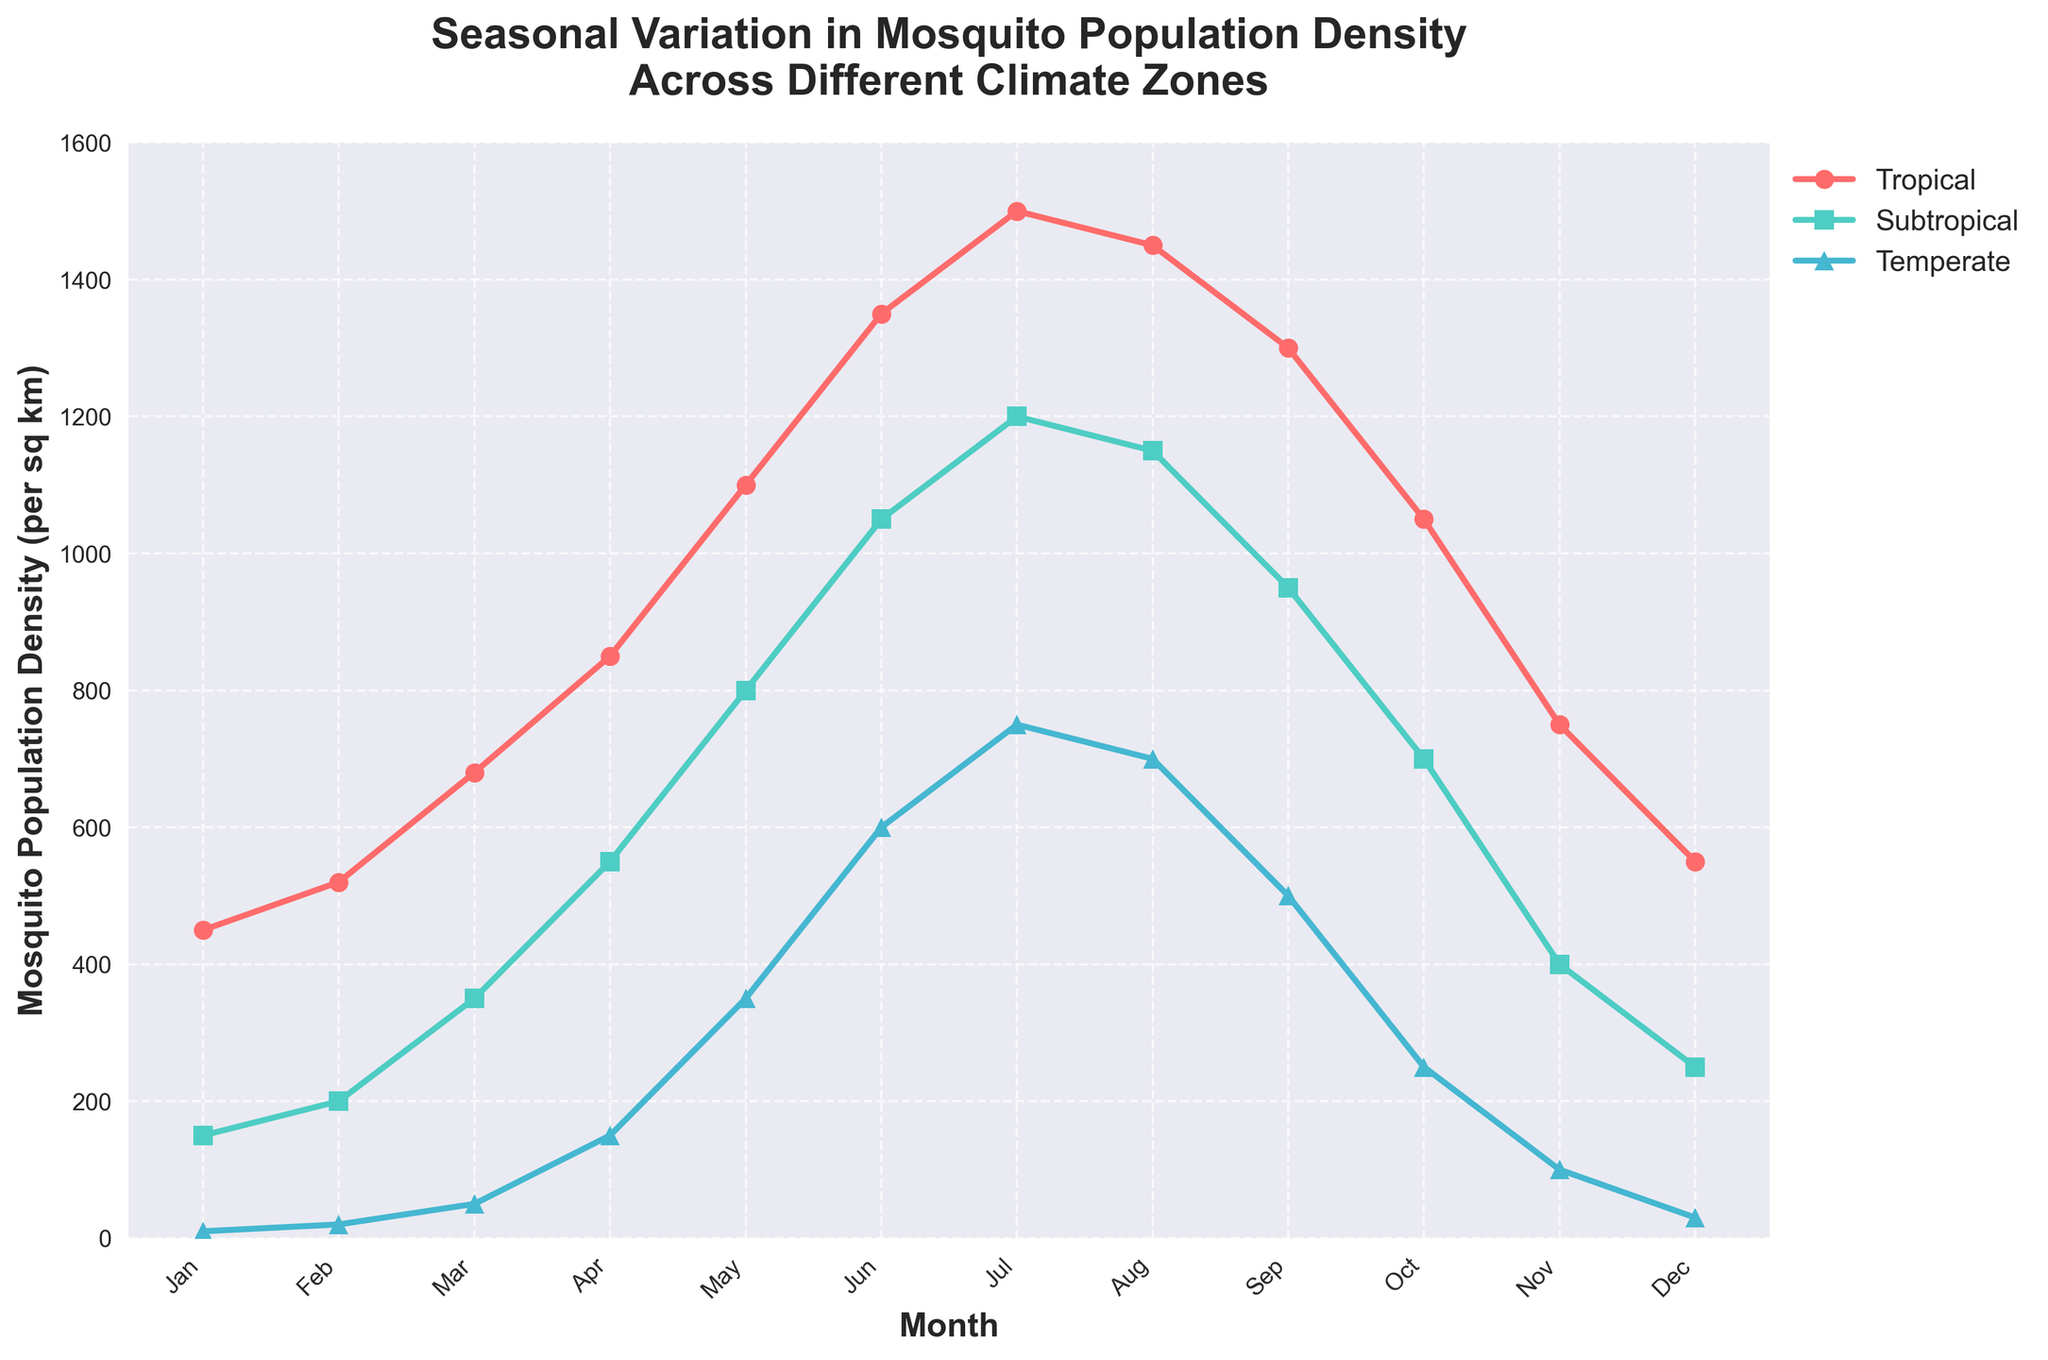Which climate zone has the highest mosquito population density in August? To find the answer, observe the density values for August across different climate zones. Tropical: 1450, Subtropical: 1150, Temperate: 700. The highest value is in the Tropical zone.
Answer: Tropical What is the average mosquito population density in the Temperate zone for the months of May, June, and July? First, note the population densities for May, June, and July in the Temperate zone: 350, 600, and 750. Sum these values: 350 + 600 + 750 = 1700. Then, divide by 3 (number of months) to get the average: 1700 / 3 ≈ 566.67.
Answer: 566.67 Which month shows the largest increase in mosquito population density from the previous month in the Subtropical zone? Calculate the difference between consecutive months' densities for the Subtropical zone and identify the month with the largest increase. Differences: Jan-Feb 50, Feb-Mar 150, Mar-Apr 200, Apr-May 250, May-Jun 250, Jun-Jul 150, Jul-Aug -50, Aug-Sep -200, Sep-Oct -250, Oct-Nov -300, Nov-Dec -150. Largest increase is from Apr to May (250).
Answer: May In which climate zone is the variation in mosquito population density the least throughout the year? Calculate the range (max - min) for each climate zone. Tropical: 1500 - 450 = 1050, Subtropical: 1200 - 150 = 1050, Temperate: 750 - 10 = 740. The smallest range is in the Temperate zone.
Answer: Temperate Compare the mosquito population densities in January among all climate zones. Which zone has the lowest density, and what is the density value? Note the densities for January: Tropical: 450, Subtropical: 150, Temperate: 10. The lowest density is in the Temperate zone with a value of 10.
Answer: Temperate, 10 How does the mosquito population density in the Tropical zone in July compare to that in the Subtropical zone in July? Check the values for July in both zones: Tropical: 1500, Subtropical: 1200. Tropical density is 300 higher than Subtropical.
Answer: 1500 is 300 higher Identify the month where the mosquito population density peaks for each climate zone. What are the peak densities? Determine the month with the highest population density for each zone and the respective density: Tropical: July (1500), Subtropical: July (1200), Temperate: July (750).
Answer: Tropical: July (1500), Subtropical: July (1200), Temperate: July (750) Which month experiences the greatest decline in mosquito population density from the previous month in the Temperate zone? Calculate the differences between consecutive months in the Temperate zone and identify the greatest decline. Differences: Jan-Feb 10, Feb-Mar 30, Mar-Apr 100, Apr-May 200, May-Jun 250, Jun-Jul 150, Jul-Aug -50, Aug-Sep -200, Sep-Oct -250, Oct-Nov -150, Nov-Dec -70. The greatest decline is from Sep to Oct (250).
Answer: October What is the cumulative mosquito population density for the Tropical zone over the first quarter of the year (January to March)? Sum the densities for January, February, and March in the Tropical zone: 450 + 520 + 680 = 1650.
Answer: 1650 